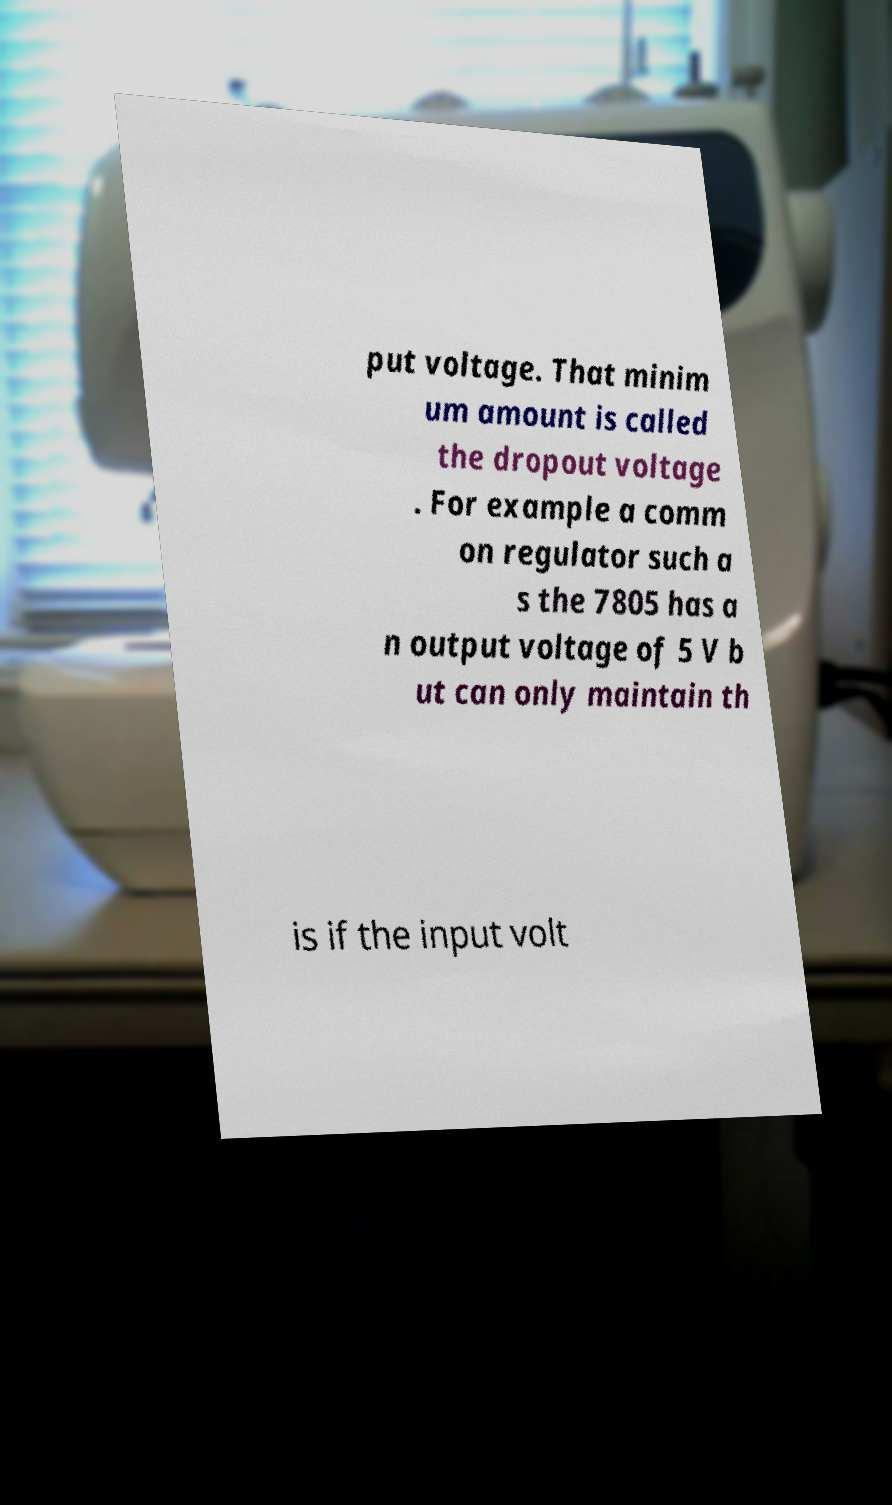I need the written content from this picture converted into text. Can you do that? put voltage. That minim um amount is called the dropout voltage . For example a comm on regulator such a s the 7805 has a n output voltage of 5 V b ut can only maintain th is if the input volt 